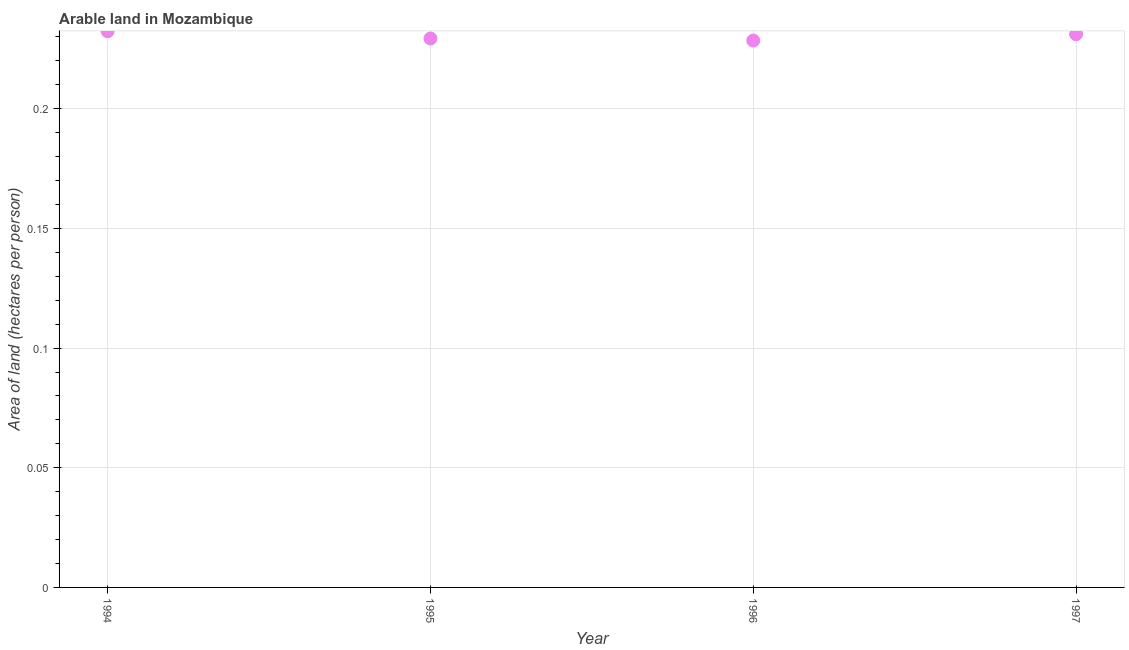What is the area of arable land in 1994?
Your answer should be compact. 0.23. Across all years, what is the maximum area of arable land?
Your answer should be compact. 0.23. Across all years, what is the minimum area of arable land?
Your answer should be compact. 0.23. In which year was the area of arable land minimum?
Your response must be concise. 1996. What is the sum of the area of arable land?
Keep it short and to the point. 0.92. What is the difference between the area of arable land in 1996 and 1997?
Keep it short and to the point. -0. What is the average area of arable land per year?
Offer a very short reply. 0.23. What is the median area of arable land?
Provide a succinct answer. 0.23. In how many years, is the area of arable land greater than 0.18000000000000002 hectares per person?
Offer a very short reply. 4. Do a majority of the years between 1995 and 1994 (inclusive) have area of arable land greater than 0.14 hectares per person?
Your answer should be compact. No. What is the ratio of the area of arable land in 1995 to that in 1997?
Your answer should be compact. 0.99. What is the difference between the highest and the second highest area of arable land?
Your answer should be very brief. 0. Is the sum of the area of arable land in 1995 and 1996 greater than the maximum area of arable land across all years?
Keep it short and to the point. Yes. What is the difference between the highest and the lowest area of arable land?
Offer a very short reply. 0. In how many years, is the area of arable land greater than the average area of arable land taken over all years?
Provide a succinct answer. 2. Does the area of arable land monotonically increase over the years?
Make the answer very short. No. How many dotlines are there?
Your answer should be compact. 1. How many years are there in the graph?
Offer a terse response. 4. What is the difference between two consecutive major ticks on the Y-axis?
Keep it short and to the point. 0.05. What is the title of the graph?
Give a very brief answer. Arable land in Mozambique. What is the label or title of the Y-axis?
Your answer should be very brief. Area of land (hectares per person). What is the Area of land (hectares per person) in 1994?
Provide a succinct answer. 0.23. What is the Area of land (hectares per person) in 1995?
Your answer should be very brief. 0.23. What is the Area of land (hectares per person) in 1996?
Provide a succinct answer. 0.23. What is the Area of land (hectares per person) in 1997?
Offer a terse response. 0.23. What is the difference between the Area of land (hectares per person) in 1994 and 1995?
Provide a short and direct response. 0. What is the difference between the Area of land (hectares per person) in 1994 and 1996?
Your answer should be very brief. 0. What is the difference between the Area of land (hectares per person) in 1994 and 1997?
Your answer should be compact. 0. What is the difference between the Area of land (hectares per person) in 1995 and 1996?
Make the answer very short. 0. What is the difference between the Area of land (hectares per person) in 1995 and 1997?
Your answer should be compact. -0. What is the difference between the Area of land (hectares per person) in 1996 and 1997?
Offer a terse response. -0. What is the ratio of the Area of land (hectares per person) in 1995 to that in 1997?
Make the answer very short. 0.99. What is the ratio of the Area of land (hectares per person) in 1996 to that in 1997?
Offer a terse response. 0.99. 